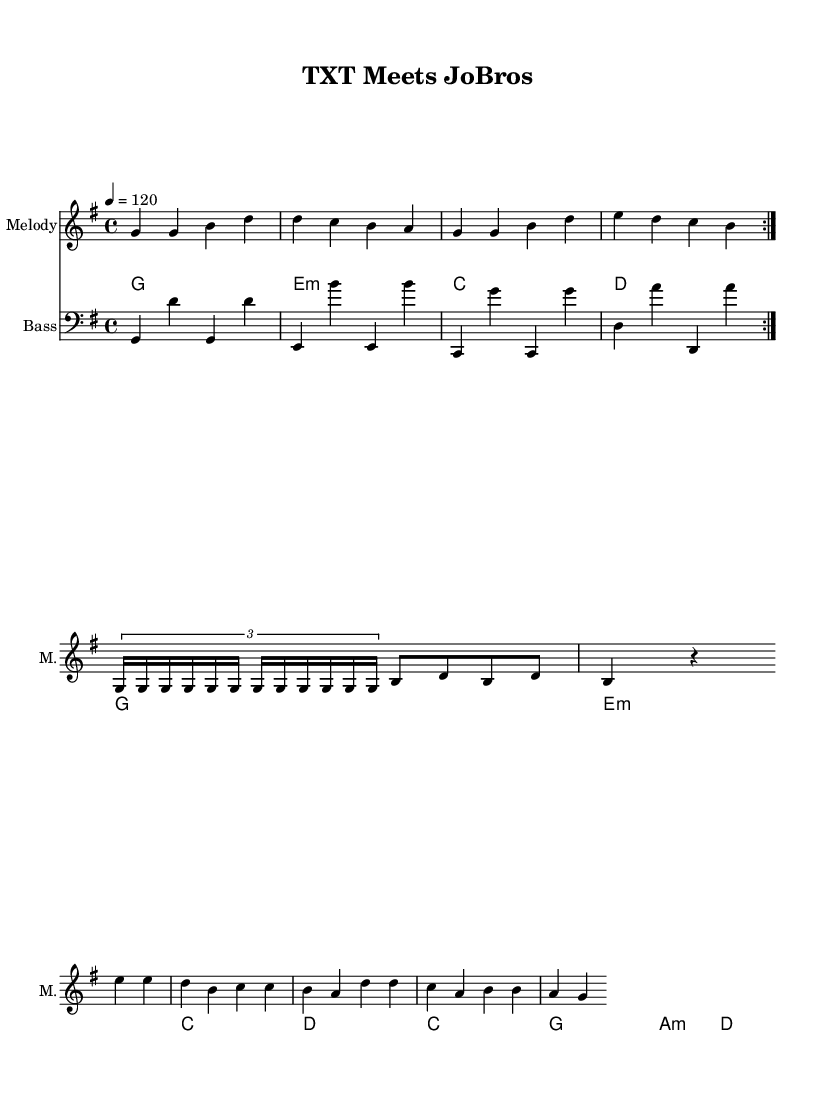What is the key signature of this music? The key signature is G major, which has one sharp (F#). This is indicated at the beginning of the sheet music before the staff.
Answer: G major What is the time signature of the piece? The time signature is 4/4, as shown right after the key signature. This means there are four beats in each measure, and the quarter note gets one beat.
Answer: 4/4 What is the tempo marking for this music? The tempo marking is 120 beats per minute, indicated at the beginning of the score with the tempo symbol. This indicates the speed at which the piece should be played.
Answer: 120 How many distinct sections are there in the score? The score contains three distinct sections: the chorus, the verse, and the bridge. This can be identified by the repetition and the arrangement of the musical parts.
Answer: Three What chords are used in the chorus section? The chords in the chorus section are G, E minor, C, and D. This information is found in the chord names written above the staff that correspond to the melody of the chorus.
Answer: G, E minor, C, D What is the note pattern for the bridge section? The note pattern for the bridge section features sequences like E, E, D, B, C, C, B, A, and so on, which includes a mix of half and quarter notes. You can find this information in the written notes of the bridge part in the sheet music.
Answer: E, E, D, B, C, C, B, A How many times is the chorus repeated? The chorus is repeated two times, as indicated by the repeat signs after the chorus in the score. This tells the musician to play that section twice before moving on.
Answer: Two 